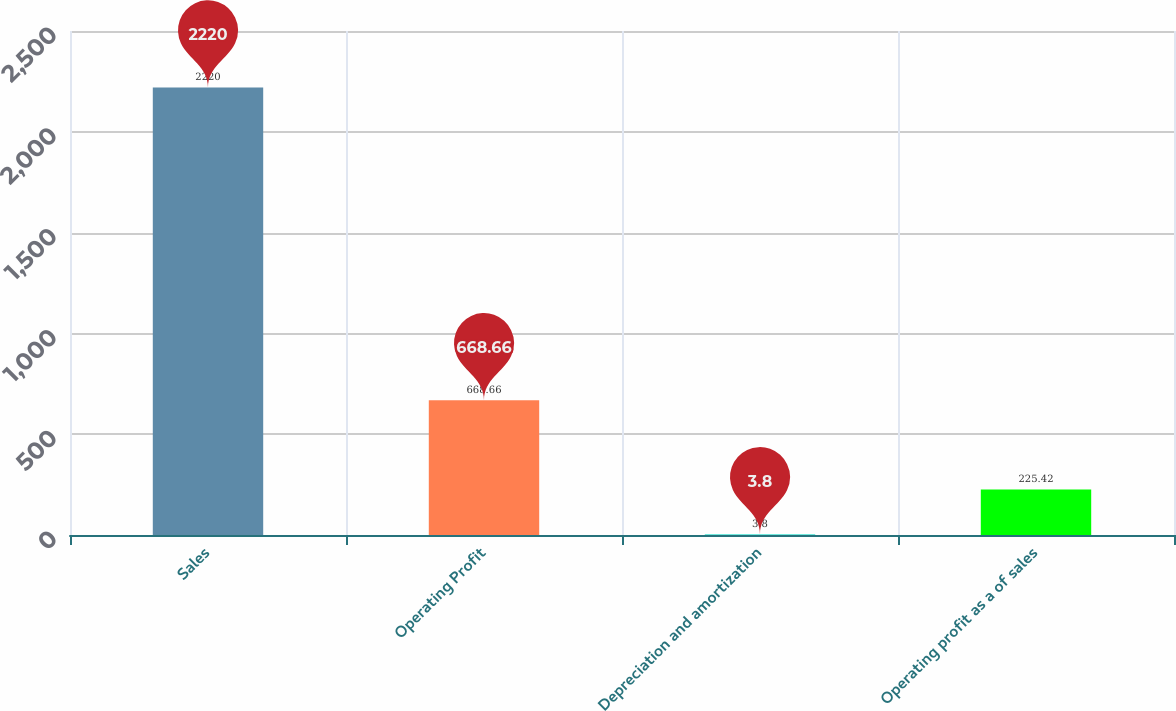Convert chart to OTSL. <chart><loc_0><loc_0><loc_500><loc_500><bar_chart><fcel>Sales<fcel>Operating Profit<fcel>Depreciation and amortization<fcel>Operating profit as a of sales<nl><fcel>2220<fcel>668.66<fcel>3.8<fcel>225.42<nl></chart> 